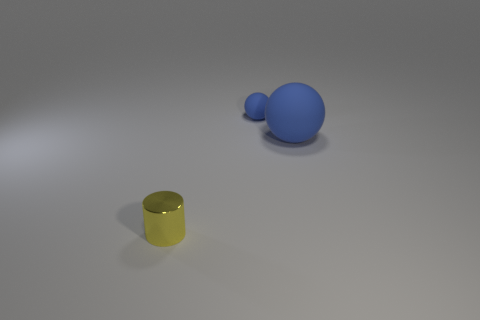There is a big matte ball; does it have the same color as the tiny thing that is behind the yellow metallic object?
Your answer should be very brief. Yes. Is there a tiny matte thing of the same shape as the big blue thing?
Your response must be concise. Yes. How many other things are the same shape as the yellow thing?
Give a very brief answer. 0. There is a thing that is both in front of the small blue ball and behind the tiny yellow metallic cylinder; what is its shape?
Provide a succinct answer. Sphere. How big is the ball left of the large blue matte object?
Your answer should be very brief. Small. Are there fewer blue balls to the right of the small blue rubber thing than shiny cylinders behind the large sphere?
Your answer should be very brief. No. How big is the object that is in front of the tiny blue rubber sphere and on the right side of the yellow metal thing?
Provide a succinct answer. Large. There is a tiny thing in front of the matte ball that is on the left side of the big blue thing; are there any objects that are right of it?
Offer a very short reply. Yes. Is there a small object?
Give a very brief answer. Yes. Is the number of things right of the tiny yellow thing greater than the number of big blue matte spheres right of the big blue sphere?
Make the answer very short. Yes. 